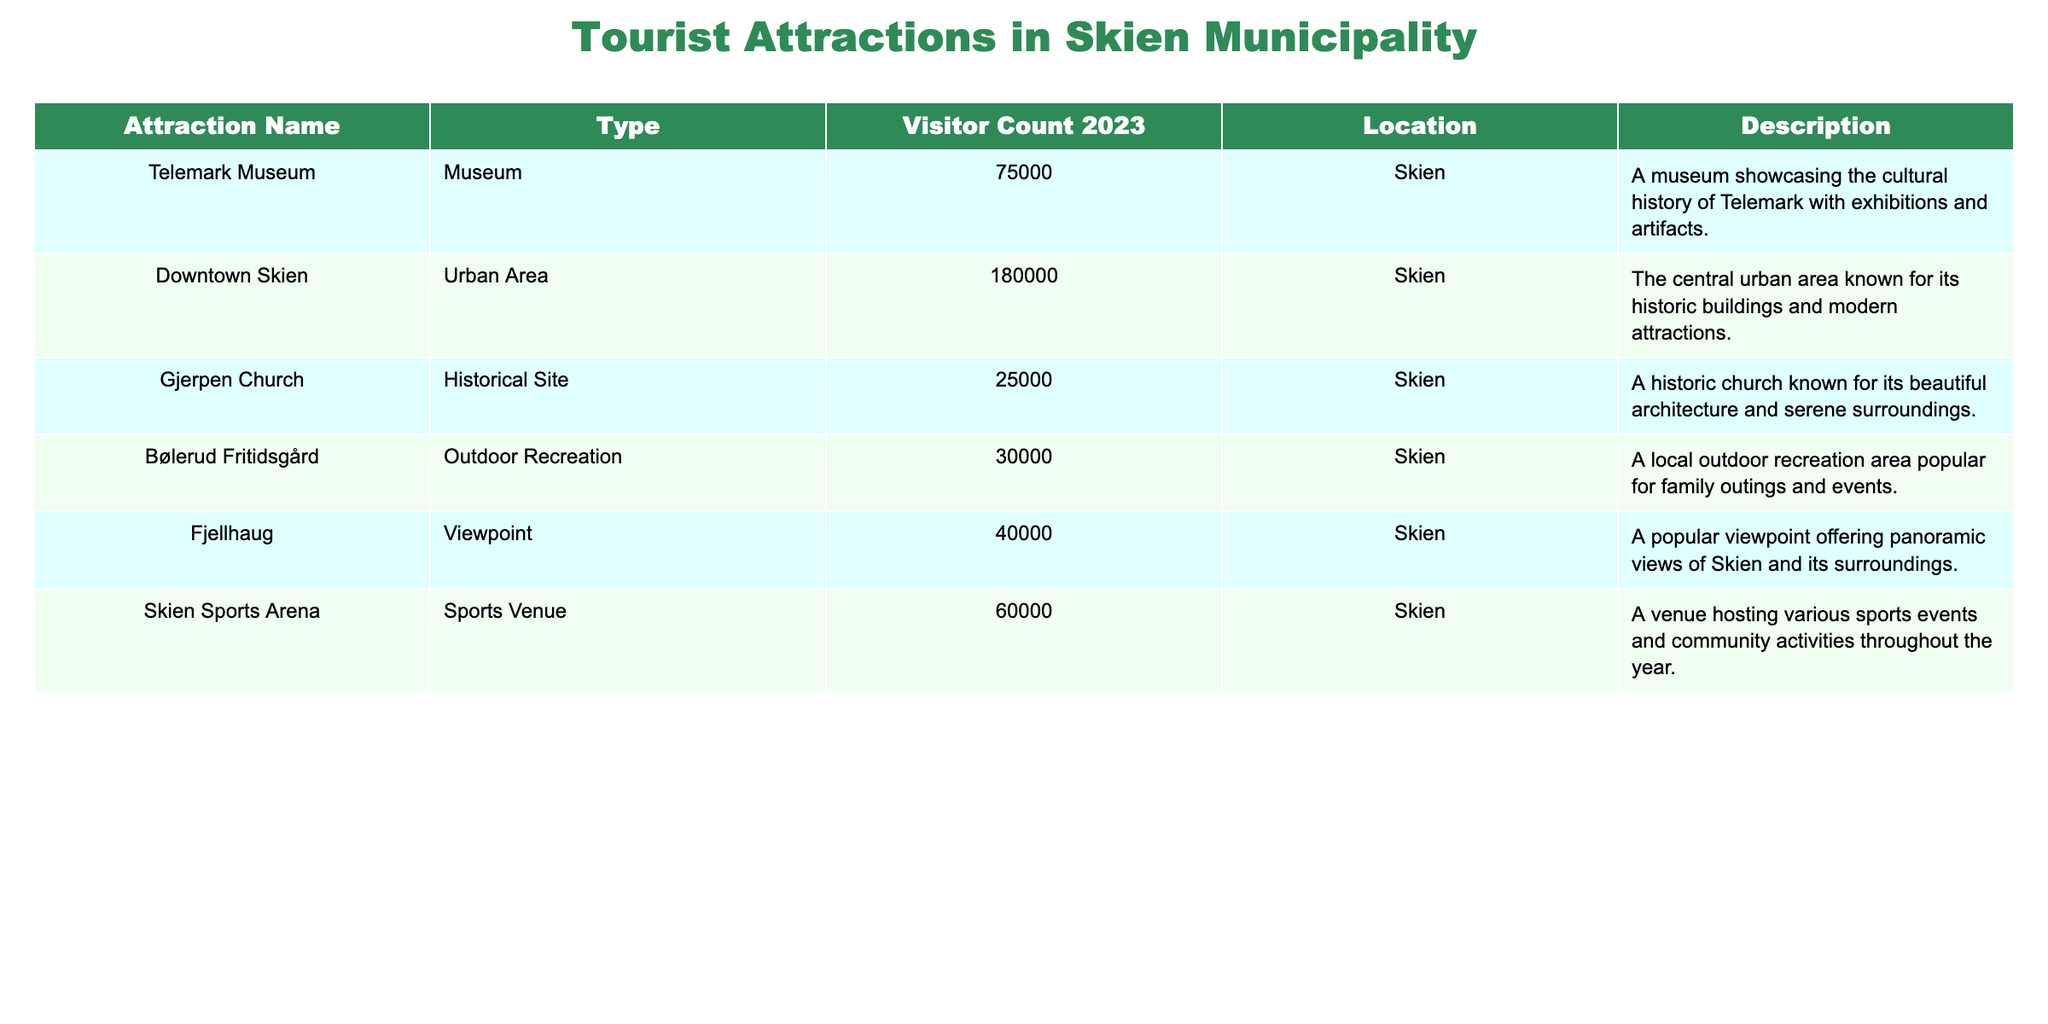What is the visitor count for Downtown Skien in 2023? The table lists the visitor count for Downtown Skien as 180,000.
Answer: 180000 Which attraction had the least number of visitors in 2023? By comparing the visitor counts in the table, Gjerpen Church had the least number of visitors at 25,000.
Answer: Gjerpen Church What is the total visitor count for all attractions listed? Adding the visitor counts: 75,000 + 180,000 + 25,000 + 30,000 + 40,000 + 60,000 = 410,000.
Answer: 410000 Is the Skien Sports Arena considered an outdoor recreation area? The table categorizes Skien Sports Arena as a sports venue, not an outdoor recreation area, so the answer is no.
Answer: No What is the difference in visitor count between Downtown Skien and Fjellhaug? The visitor count for Downtown Skien is 180,000 and for Fjellhaug it is 40,000, so the difference is 180,000 - 40,000 = 140,000.
Answer: 140000 What percentage of the total visitors does Telemark Museum represent? Telemark Museum has 75,000 visitors out of a total of 410,000. Therefore, (75,000 / 410,000) * 100 ≈ 18.29%.
Answer: 18.29% Which type of attraction is most popular based on visitor counts, and how many visitors did it attract? The urban area (Downtown Skien) attracted the most visitors with 180,000, making it the most popular type of attraction.
Answer: Urban Area: 180000 If Bølerud Fritidsgård and Gjerpen Church were combined, what would be their total visitor count? The visitor count for Bølerud Fritidsgård is 30,000 and for Gjerpen Church it is 25,000, so the total is 30,000 + 25,000 = 55,000.
Answer: 55000 What type of attraction is Fjellhaug? The table classifies Fjellhaug as a viewpoint.
Answer: Viewpoint Which two attractions have a combined visitor count greater than 130,000? Downtown Skien (180,000) and Skien Sports Arena (60,000) combined total 240,000, which is greater than 130,000.
Answer: Yes 